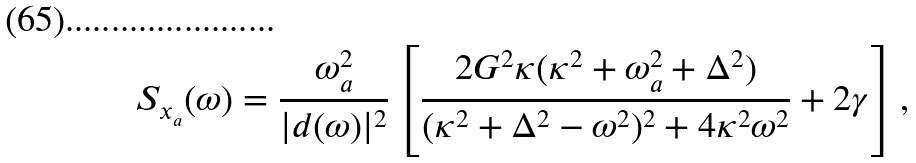Convert formula to latex. <formula><loc_0><loc_0><loc_500><loc_500>S _ { x _ { a } } ( \omega ) = \frac { \omega ^ { 2 } _ { a } } { | d ( \omega ) | ^ { 2 } } \left [ \frac { 2 G ^ { 2 } \kappa ( \kappa ^ { 2 } + \omega ^ { 2 } _ { a } + \Delta ^ { 2 } ) } { ( \kappa ^ { 2 } + \Delta ^ { 2 } - \omega ^ { 2 } ) ^ { 2 } + 4 \kappa ^ { 2 } \omega ^ { 2 } } + 2 \gamma \right ] ,</formula> 